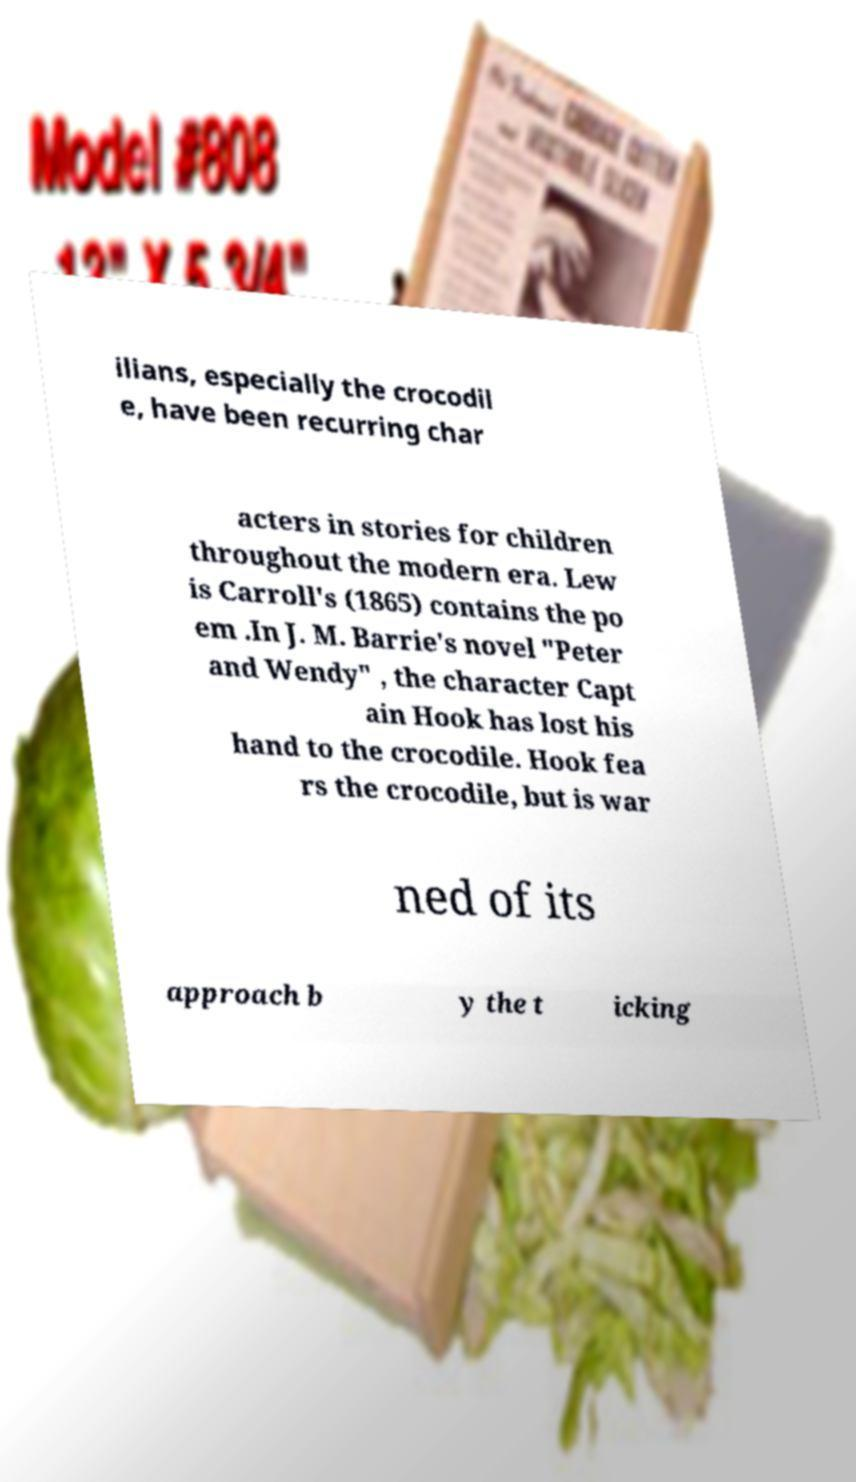Can you accurately transcribe the text from the provided image for me? ilians, especially the crocodil e, have been recurring char acters in stories for children throughout the modern era. Lew is Carroll's (1865) contains the po em .In J. M. Barrie's novel "Peter and Wendy" , the character Capt ain Hook has lost his hand to the crocodile. Hook fea rs the crocodile, but is war ned of its approach b y the t icking 